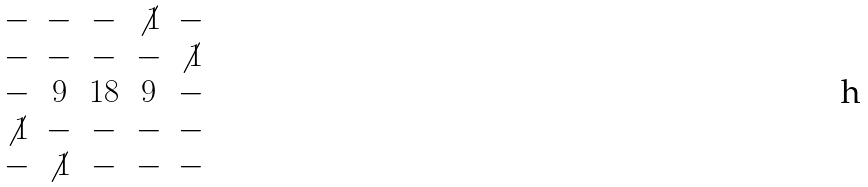Convert formula to latex. <formula><loc_0><loc_0><loc_500><loc_500>\begin{matrix} - & - & - & \not 1 & - \\ - & - & - & - & \not 1 \\ - & 9 & 1 8 & 9 & - \\ \not 1 & - & - & - & - \\ - & \not 1 & - & - & - \\ \end{matrix}</formula> 